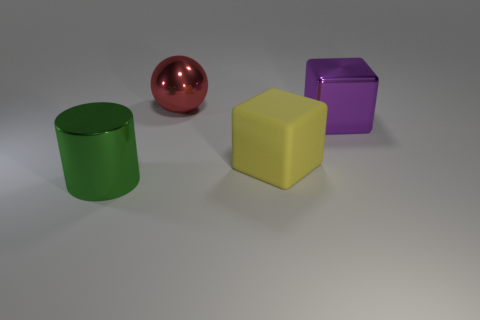Add 1 big metallic balls. How many objects exist? 5 Subtract all blue cubes. Subtract all green cylinders. How many cubes are left? 2 Subtract all purple blocks. How many green spheres are left? 0 Subtract all small blue matte objects. Subtract all large yellow matte things. How many objects are left? 3 Add 2 cylinders. How many cylinders are left? 3 Add 3 metal cylinders. How many metal cylinders exist? 4 Subtract 0 red cylinders. How many objects are left? 4 Subtract all balls. How many objects are left? 3 